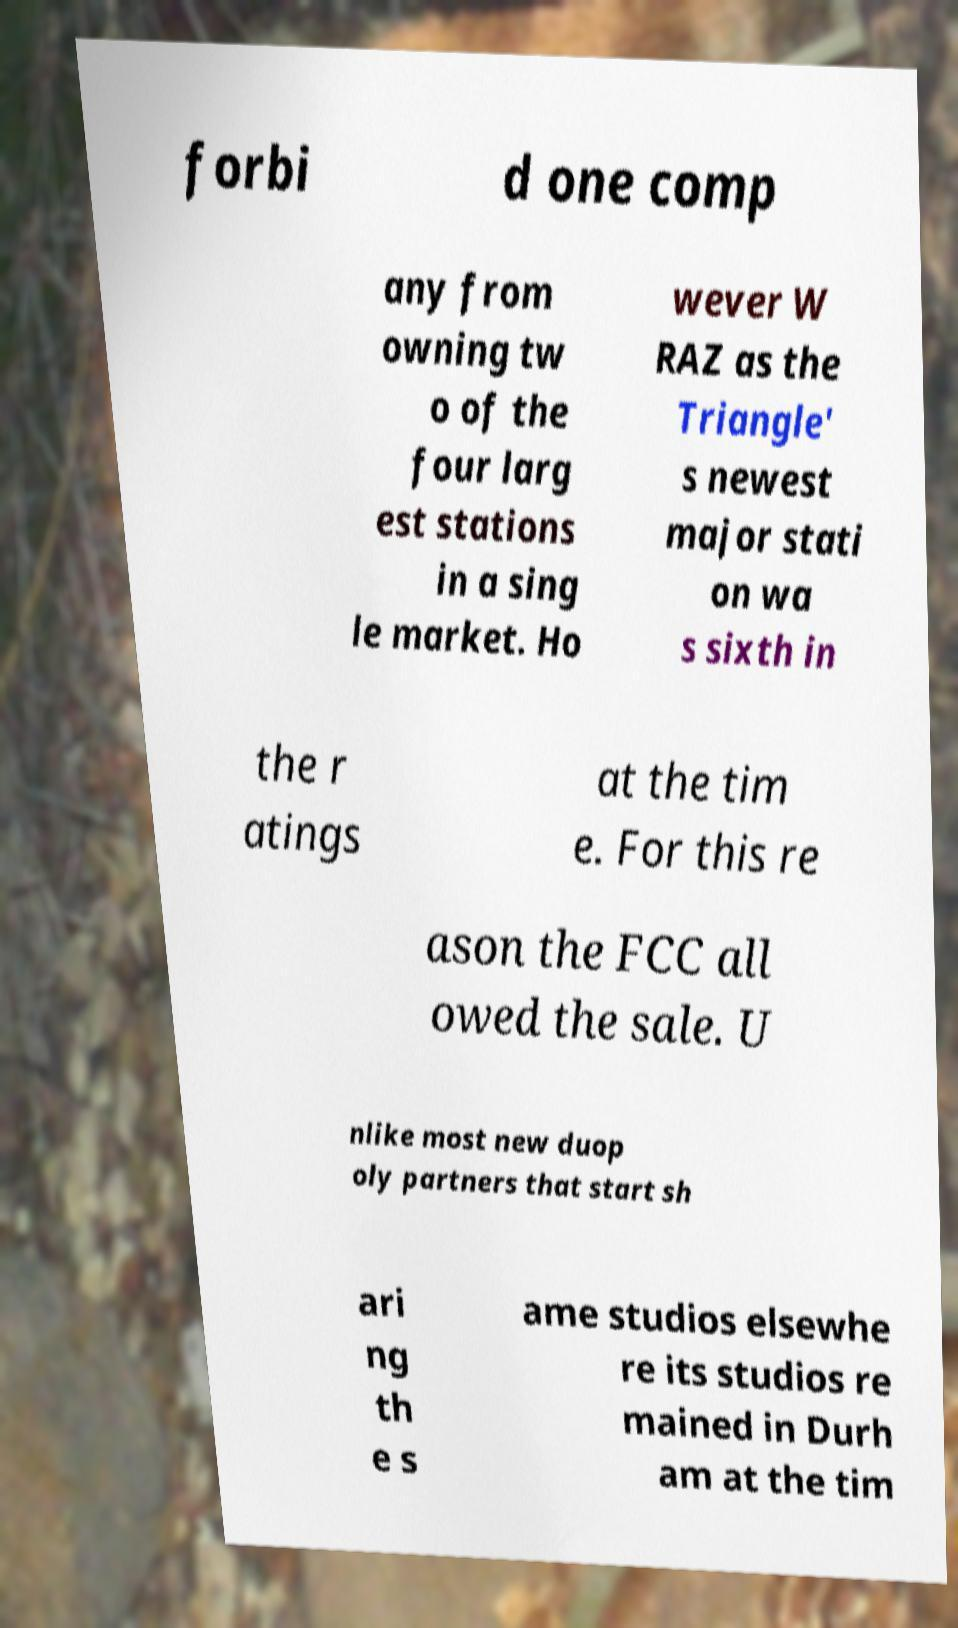Could you assist in decoding the text presented in this image and type it out clearly? forbi d one comp any from owning tw o of the four larg est stations in a sing le market. Ho wever W RAZ as the Triangle' s newest major stati on wa s sixth in the r atings at the tim e. For this re ason the FCC all owed the sale. U nlike most new duop oly partners that start sh ari ng th e s ame studios elsewhe re its studios re mained in Durh am at the tim 